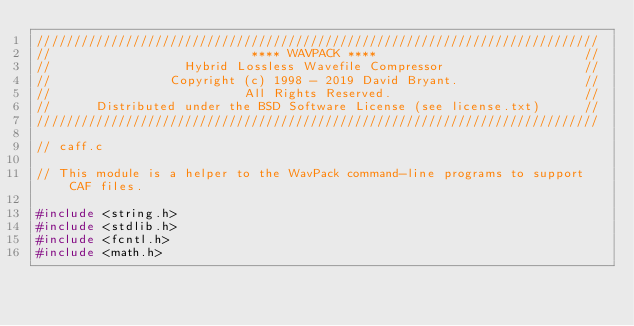<code> <loc_0><loc_0><loc_500><loc_500><_C_>////////////////////////////////////////////////////////////////////////////
//                           **** WAVPACK ****                            //
//                  Hybrid Lossless Wavefile Compressor                   //
//                Copyright (c) 1998 - 2019 David Bryant.                 //
//                          All Rights Reserved.                          //
//      Distributed under the BSD Software License (see license.txt)      //
////////////////////////////////////////////////////////////////////////////

// caff.c

// This module is a helper to the WavPack command-line programs to support CAF files.

#include <string.h>
#include <stdlib.h>
#include <fcntl.h>
#include <math.h></code> 